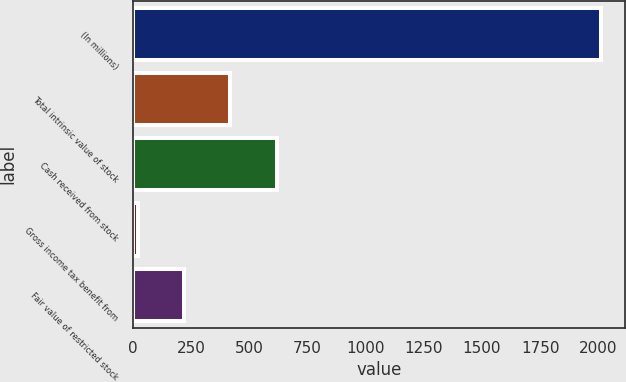Convert chart. <chart><loc_0><loc_0><loc_500><loc_500><bar_chart><fcel>(In millions)<fcel>Total intrinsic value of stock<fcel>Cash received from stock<fcel>Gross income tax benefit from<fcel>Fair value of restricted stock<nl><fcel>2012<fcel>418.4<fcel>617.6<fcel>20<fcel>219.2<nl></chart> 